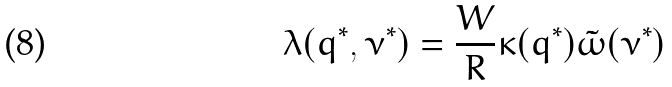Convert formula to latex. <formula><loc_0><loc_0><loc_500><loc_500>\lambda ( q ^ { * } , \nu ^ { * } ) = \frac { W } { R } \kappa ( q ^ { * } ) \tilde { \omega } ( \nu ^ { * } )</formula> 